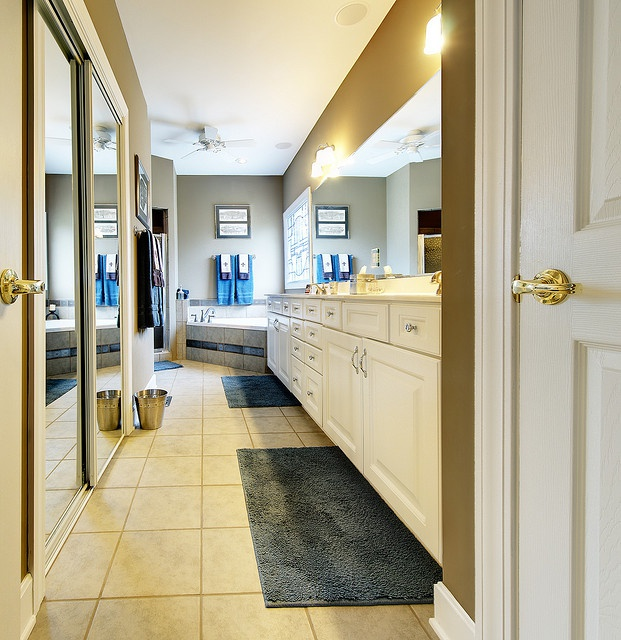Describe the objects in this image and their specific colors. I can see sink in tan, lightyellow, and khaki tones and sink in tan, lightgray, and darkgray tones in this image. 